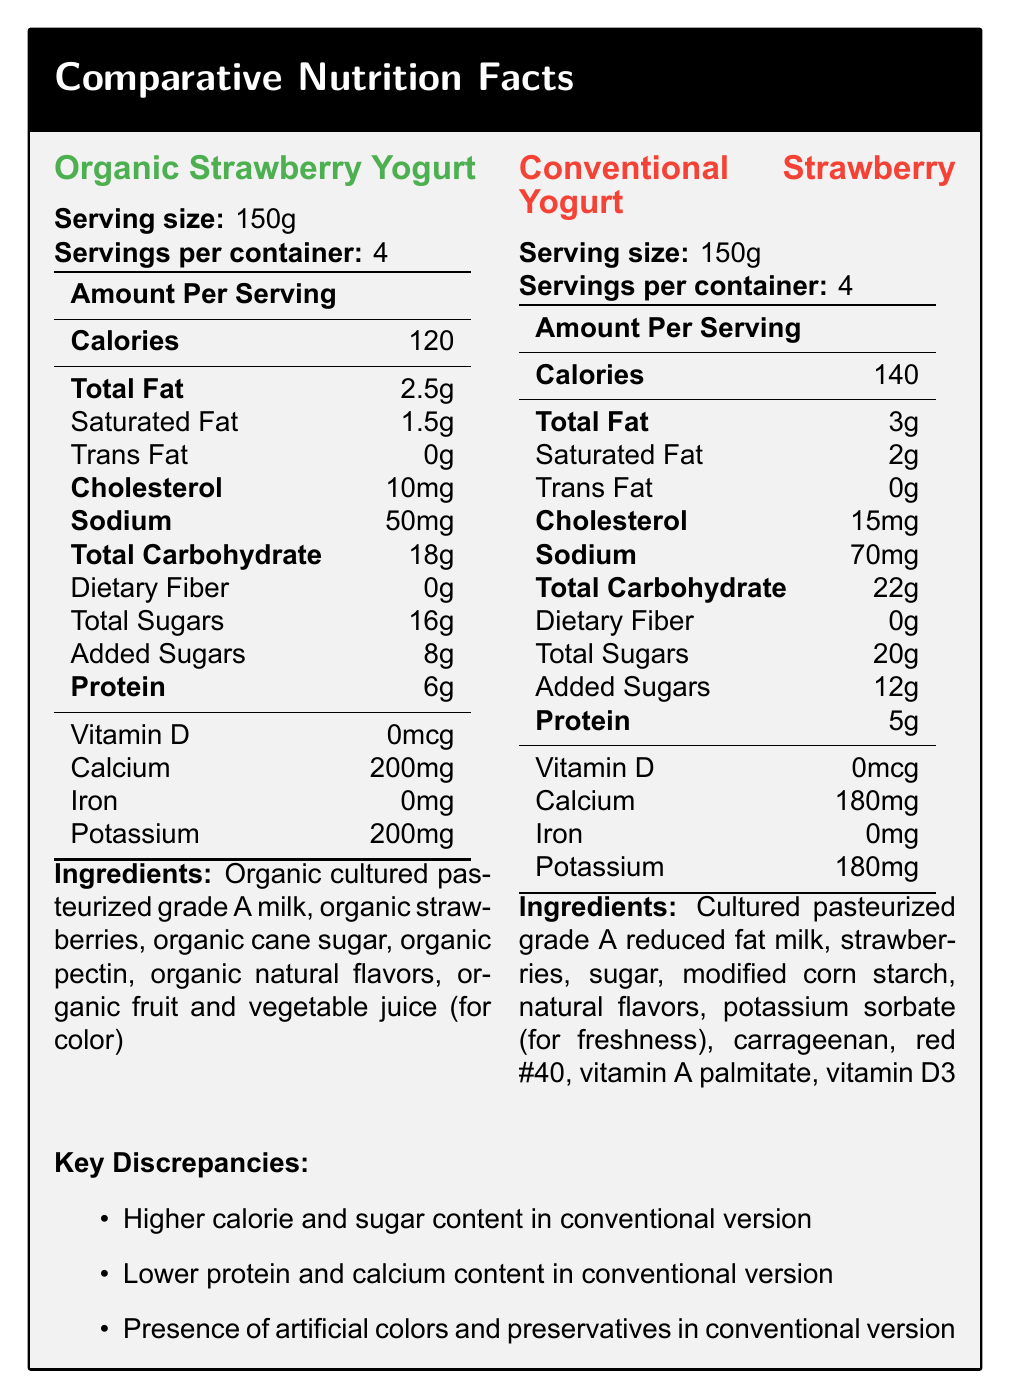what is the serving size for both versions of the Strawberry Yogurt? The serving size for both the organic and conventional versions is listed as 150g in the document.
Answer: 150g Which version has higher calories per serving? The conventional version has 140 calories per serving, while the organic version has 120 calories per serving.
Answer: Conventional What is the total fat content in the organic version? According to the document, the total fat content in the organic version is 2.5g per serving.
Answer: 2.5g How much calcium is in one serving of the conventional yogurt? The conventional version contains 180mg of calcium per serving.
Answer: 180mg List one artificial ingredient found in the conventional version but not in the organic version. The conventional yogurt contains Red #40, which is an artificial color, not present in the organic version.
Answer: Red #40 Which version of the yogurt has more added sugars? The conventional version has 12g of added sugars, while the organic version has 8g.
Answer: Conventional Which type of fat has a different amount between the two versions? A. Trans Fat B. Saturated Fat C. Total Fat D. Both B and C The conventional yogurt has 2g of saturated fat and 3g of total fat, while the organic version has 1.5g of saturated fat and 2.5g of total fat.
Answer: D. Both B and C Which version has higher protein content? A. Organic B. Conventional The organic version has 6g of protein, while the conventional version has 5g.
Answer: A. Organic Does the conventional yogurt contain dietary fiber? Both the organic and conventional versions list dietary fiber as 0g.
Answer: No Summarize the main ideas presented in the entire document. The document provides a detailed nutritional comparison between organic and conventional strawberry yogurt. It points out key discrepancies like higher calorie and sugar content in the conventional version, the presence of artificial additives in the conventional version, and slightly better nutritional values in the organic version. It also mentions potential policy implications and alternative approaches.
Answer: The document compares the nutrition facts of organic and conventional strawberry yogurt, highlighting differences in calories, sugar content, protein, and artificial additives. The organic version generally has fewer calories, less added sugar, and more protein, while the conventional version contains more preservatives and artificial colors. The document also lists potential implications for food policy and suggests alternative approaches. Why is there a call for stricter labeling requirements for conventional products? The document suggests stricter labeling requirements for conventional products to make consumers more aware of the artificial additives and the nutritional differences, which could impact their health choices.
Answer: Due to the presence of artificial additives and significant differences in nutritional content compared to organic products What is the impact of artificial additives in conventional foods on public health? The document mentions potential regulation of artificial additives but does not provide detailed information on their specific health impacts.
Answer: Not enough information Are the farming practices used in producing the yogurt disclosed in the document? The document does not provide specific details on the farming practices beyond indicating whether the yogurt is organic or conventional.
Answer: No 